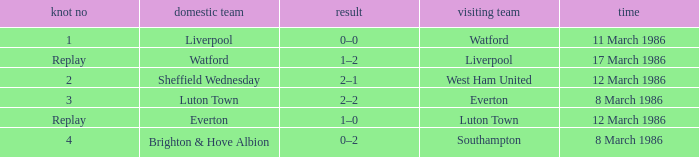What tie happened with Southampton? 4.0. 